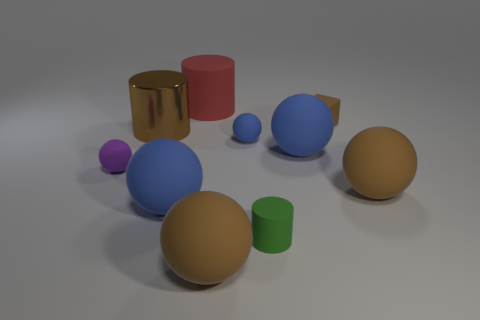Can you tell me how many objects are in total and what colors they are? In the image, there are a total of eight objects consisting of varying colors. There are three blue objects, two yellow objects (one of which is quite small), one purple, one red, and one green object. Are there any reflective surfaces visible? Yes, some objects have reflective surfaces. The golden cylinder and the large blue sphere both have a glossy finish that reflects the environment, adding a sense of depth to the scene. 